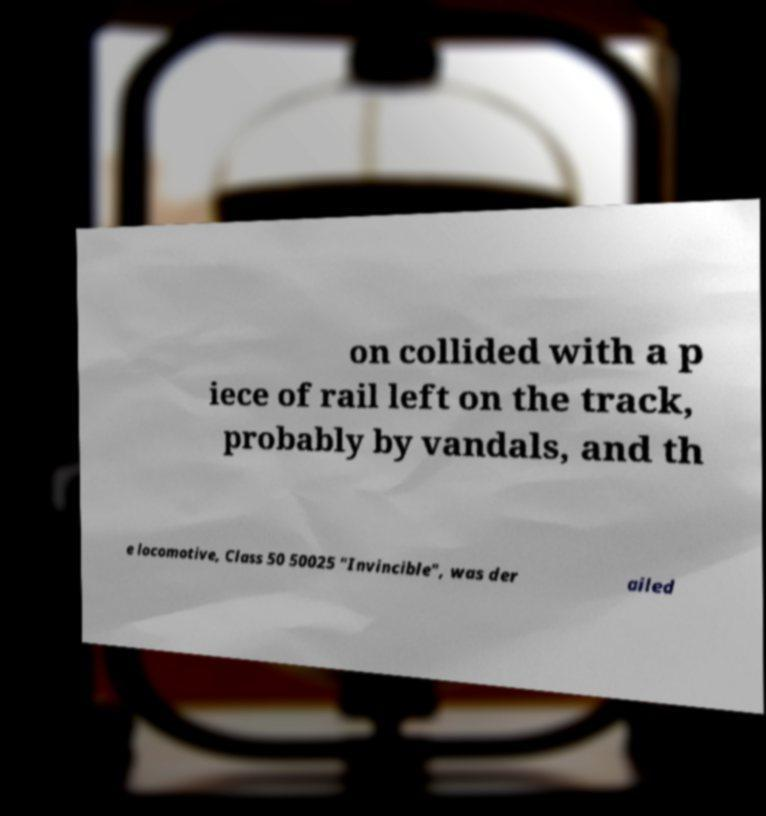Please read and relay the text visible in this image. What does it say? on collided with a p iece of rail left on the track, probably by vandals, and th e locomotive, Class 50 50025 "Invincible", was der ailed 